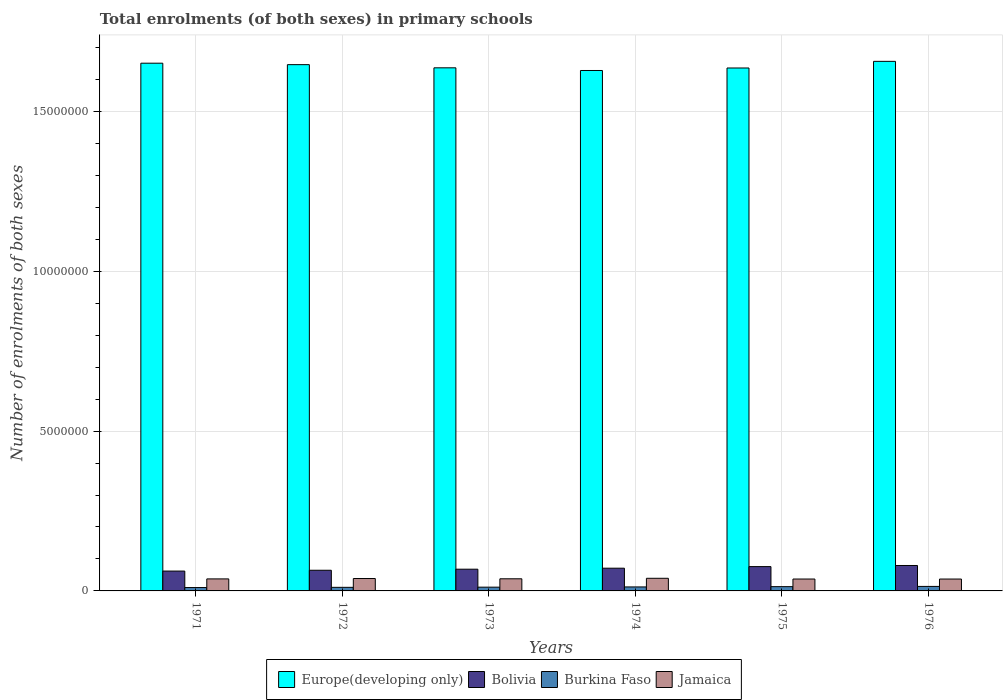How many different coloured bars are there?
Your answer should be very brief. 4. How many groups of bars are there?
Your answer should be very brief. 6. Are the number of bars per tick equal to the number of legend labels?
Your answer should be very brief. Yes. Are the number of bars on each tick of the X-axis equal?
Ensure brevity in your answer.  Yes. How many bars are there on the 3rd tick from the right?
Provide a succinct answer. 4. In how many cases, is the number of bars for a given year not equal to the number of legend labels?
Give a very brief answer. 0. What is the number of enrolments in primary schools in Jamaica in 1975?
Give a very brief answer. 3.72e+05. Across all years, what is the maximum number of enrolments in primary schools in Jamaica?
Keep it short and to the point. 3.95e+05. Across all years, what is the minimum number of enrolments in primary schools in Europe(developing only)?
Offer a very short reply. 1.63e+07. In which year was the number of enrolments in primary schools in Europe(developing only) maximum?
Offer a very short reply. 1976. In which year was the number of enrolments in primary schools in Europe(developing only) minimum?
Your response must be concise. 1974. What is the total number of enrolments in primary schools in Europe(developing only) in the graph?
Your answer should be very brief. 9.86e+07. What is the difference between the number of enrolments in primary schools in Jamaica in 1971 and that in 1974?
Provide a succinct answer. -1.90e+04. What is the difference between the number of enrolments in primary schools in Bolivia in 1973 and the number of enrolments in primary schools in Burkina Faso in 1976?
Offer a very short reply. 5.38e+05. What is the average number of enrolments in primary schools in Burkina Faso per year?
Offer a terse response. 1.22e+05. In the year 1971, what is the difference between the number of enrolments in primary schools in Bolivia and number of enrolments in primary schools in Burkina Faso?
Offer a very short reply. 5.16e+05. What is the ratio of the number of enrolments in primary schools in Burkina Faso in 1973 to that in 1974?
Make the answer very short. 0.94. Is the number of enrolments in primary schools in Burkina Faso in 1971 less than that in 1974?
Keep it short and to the point. Yes. Is the difference between the number of enrolments in primary schools in Bolivia in 1972 and 1975 greater than the difference between the number of enrolments in primary schools in Burkina Faso in 1972 and 1975?
Provide a succinct answer. No. What is the difference between the highest and the second highest number of enrolments in primary schools in Bolivia?
Ensure brevity in your answer.  3.46e+04. What is the difference between the highest and the lowest number of enrolments in primary schools in Bolivia?
Make the answer very short. 1.75e+05. What does the 4th bar from the left in 1975 represents?
Make the answer very short. Jamaica. What does the 4th bar from the right in 1972 represents?
Make the answer very short. Europe(developing only). Are all the bars in the graph horizontal?
Ensure brevity in your answer.  No. How many years are there in the graph?
Make the answer very short. 6. What is the difference between two consecutive major ticks on the Y-axis?
Your answer should be compact. 5.00e+06. Does the graph contain any zero values?
Keep it short and to the point. No. Does the graph contain grids?
Your response must be concise. Yes. What is the title of the graph?
Offer a terse response. Total enrolments (of both sexes) in primary schools. What is the label or title of the X-axis?
Your answer should be compact. Years. What is the label or title of the Y-axis?
Give a very brief answer. Number of enrolments of both sexes. What is the Number of enrolments of both sexes in Europe(developing only) in 1971?
Provide a succinct answer. 1.65e+07. What is the Number of enrolments of both sexes of Bolivia in 1971?
Give a very brief answer. 6.21e+05. What is the Number of enrolments of both sexes in Burkina Faso in 1971?
Make the answer very short. 1.05e+05. What is the Number of enrolments of both sexes of Jamaica in 1971?
Keep it short and to the point. 3.76e+05. What is the Number of enrolments of both sexes in Europe(developing only) in 1972?
Offer a terse response. 1.65e+07. What is the Number of enrolments of both sexes in Bolivia in 1972?
Provide a succinct answer. 6.46e+05. What is the Number of enrolments of both sexes in Burkina Faso in 1972?
Offer a terse response. 1.12e+05. What is the Number of enrolments of both sexes of Jamaica in 1972?
Make the answer very short. 3.88e+05. What is the Number of enrolments of both sexes of Europe(developing only) in 1973?
Offer a terse response. 1.64e+07. What is the Number of enrolments of both sexes of Bolivia in 1973?
Make the answer very short. 6.80e+05. What is the Number of enrolments of both sexes in Burkina Faso in 1973?
Provide a succinct answer. 1.18e+05. What is the Number of enrolments of both sexes in Jamaica in 1973?
Your response must be concise. 3.79e+05. What is the Number of enrolments of both sexes of Europe(developing only) in 1974?
Your answer should be compact. 1.63e+07. What is the Number of enrolments of both sexes of Bolivia in 1974?
Your answer should be very brief. 7.11e+05. What is the Number of enrolments of both sexes in Burkina Faso in 1974?
Offer a terse response. 1.25e+05. What is the Number of enrolments of both sexes in Jamaica in 1974?
Your response must be concise. 3.95e+05. What is the Number of enrolments of both sexes of Europe(developing only) in 1975?
Your answer should be very brief. 1.64e+07. What is the Number of enrolments of both sexes of Bolivia in 1975?
Give a very brief answer. 7.61e+05. What is the Number of enrolments of both sexes of Burkina Faso in 1975?
Keep it short and to the point. 1.34e+05. What is the Number of enrolments of both sexes of Jamaica in 1975?
Offer a very short reply. 3.72e+05. What is the Number of enrolments of both sexes in Europe(developing only) in 1976?
Ensure brevity in your answer.  1.66e+07. What is the Number of enrolments of both sexes in Bolivia in 1976?
Your answer should be very brief. 7.96e+05. What is the Number of enrolments of both sexes in Burkina Faso in 1976?
Keep it short and to the point. 1.41e+05. What is the Number of enrolments of both sexes of Jamaica in 1976?
Your answer should be very brief. 3.72e+05. Across all years, what is the maximum Number of enrolments of both sexes in Europe(developing only)?
Make the answer very short. 1.66e+07. Across all years, what is the maximum Number of enrolments of both sexes of Bolivia?
Make the answer very short. 7.96e+05. Across all years, what is the maximum Number of enrolments of both sexes of Burkina Faso?
Ensure brevity in your answer.  1.41e+05. Across all years, what is the maximum Number of enrolments of both sexes of Jamaica?
Your answer should be compact. 3.95e+05. Across all years, what is the minimum Number of enrolments of both sexes in Europe(developing only)?
Provide a succinct answer. 1.63e+07. Across all years, what is the minimum Number of enrolments of both sexes in Bolivia?
Keep it short and to the point. 6.21e+05. Across all years, what is the minimum Number of enrolments of both sexes of Burkina Faso?
Keep it short and to the point. 1.05e+05. Across all years, what is the minimum Number of enrolments of both sexes of Jamaica?
Give a very brief answer. 3.72e+05. What is the total Number of enrolments of both sexes in Europe(developing only) in the graph?
Provide a succinct answer. 9.86e+07. What is the total Number of enrolments of both sexes of Bolivia in the graph?
Offer a terse response. 4.21e+06. What is the total Number of enrolments of both sexes in Burkina Faso in the graph?
Offer a very short reply. 7.35e+05. What is the total Number of enrolments of both sexes of Jamaica in the graph?
Your answer should be compact. 2.28e+06. What is the difference between the Number of enrolments of both sexes of Europe(developing only) in 1971 and that in 1972?
Offer a terse response. 4.55e+04. What is the difference between the Number of enrolments of both sexes of Bolivia in 1971 and that in 1972?
Your answer should be compact. -2.55e+04. What is the difference between the Number of enrolments of both sexes of Burkina Faso in 1971 and that in 1972?
Keep it short and to the point. -6696. What is the difference between the Number of enrolments of both sexes in Jamaica in 1971 and that in 1972?
Keep it short and to the point. -1.17e+04. What is the difference between the Number of enrolments of both sexes in Europe(developing only) in 1971 and that in 1973?
Ensure brevity in your answer.  1.45e+05. What is the difference between the Number of enrolments of both sexes of Bolivia in 1971 and that in 1973?
Give a very brief answer. -5.87e+04. What is the difference between the Number of enrolments of both sexes of Burkina Faso in 1971 and that in 1973?
Provide a succinct answer. -1.22e+04. What is the difference between the Number of enrolments of both sexes of Jamaica in 1971 and that in 1973?
Offer a terse response. -3421. What is the difference between the Number of enrolments of both sexes in Europe(developing only) in 1971 and that in 1974?
Provide a short and direct response. 2.28e+05. What is the difference between the Number of enrolments of both sexes in Bolivia in 1971 and that in 1974?
Ensure brevity in your answer.  -9.01e+04. What is the difference between the Number of enrolments of both sexes in Burkina Faso in 1971 and that in 1974?
Ensure brevity in your answer.  -1.96e+04. What is the difference between the Number of enrolments of both sexes of Jamaica in 1971 and that in 1974?
Provide a succinct answer. -1.90e+04. What is the difference between the Number of enrolments of both sexes of Europe(developing only) in 1971 and that in 1975?
Offer a terse response. 1.50e+05. What is the difference between the Number of enrolments of both sexes in Bolivia in 1971 and that in 1975?
Your response must be concise. -1.40e+05. What is the difference between the Number of enrolments of both sexes in Burkina Faso in 1971 and that in 1975?
Your answer should be very brief. -2.83e+04. What is the difference between the Number of enrolments of both sexes in Jamaica in 1971 and that in 1975?
Give a very brief answer. 3815. What is the difference between the Number of enrolments of both sexes in Europe(developing only) in 1971 and that in 1976?
Ensure brevity in your answer.  -5.76e+04. What is the difference between the Number of enrolments of both sexes of Bolivia in 1971 and that in 1976?
Keep it short and to the point. -1.75e+05. What is the difference between the Number of enrolments of both sexes of Burkina Faso in 1971 and that in 1976?
Ensure brevity in your answer.  -3.58e+04. What is the difference between the Number of enrolments of both sexes of Jamaica in 1971 and that in 1976?
Provide a short and direct response. 4199. What is the difference between the Number of enrolments of both sexes in Europe(developing only) in 1972 and that in 1973?
Give a very brief answer. 9.94e+04. What is the difference between the Number of enrolments of both sexes in Bolivia in 1972 and that in 1973?
Keep it short and to the point. -3.32e+04. What is the difference between the Number of enrolments of both sexes of Burkina Faso in 1972 and that in 1973?
Your response must be concise. -5534. What is the difference between the Number of enrolments of both sexes in Jamaica in 1972 and that in 1973?
Provide a short and direct response. 8244. What is the difference between the Number of enrolments of both sexes of Europe(developing only) in 1972 and that in 1974?
Your answer should be very brief. 1.83e+05. What is the difference between the Number of enrolments of both sexes in Bolivia in 1972 and that in 1974?
Your answer should be very brief. -6.46e+04. What is the difference between the Number of enrolments of both sexes of Burkina Faso in 1972 and that in 1974?
Your response must be concise. -1.29e+04. What is the difference between the Number of enrolments of both sexes of Jamaica in 1972 and that in 1974?
Your answer should be compact. -7296. What is the difference between the Number of enrolments of both sexes in Europe(developing only) in 1972 and that in 1975?
Your answer should be very brief. 1.05e+05. What is the difference between the Number of enrolments of both sexes of Bolivia in 1972 and that in 1975?
Offer a very short reply. -1.15e+05. What is the difference between the Number of enrolments of both sexes of Burkina Faso in 1972 and that in 1975?
Provide a short and direct response. -2.16e+04. What is the difference between the Number of enrolments of both sexes in Jamaica in 1972 and that in 1975?
Your answer should be compact. 1.55e+04. What is the difference between the Number of enrolments of both sexes of Europe(developing only) in 1972 and that in 1976?
Provide a succinct answer. -1.03e+05. What is the difference between the Number of enrolments of both sexes in Bolivia in 1972 and that in 1976?
Offer a terse response. -1.49e+05. What is the difference between the Number of enrolments of both sexes in Burkina Faso in 1972 and that in 1976?
Provide a short and direct response. -2.91e+04. What is the difference between the Number of enrolments of both sexes of Jamaica in 1972 and that in 1976?
Provide a succinct answer. 1.59e+04. What is the difference between the Number of enrolments of both sexes in Europe(developing only) in 1973 and that in 1974?
Provide a succinct answer. 8.35e+04. What is the difference between the Number of enrolments of both sexes in Bolivia in 1973 and that in 1974?
Make the answer very short. -3.14e+04. What is the difference between the Number of enrolments of both sexes in Burkina Faso in 1973 and that in 1974?
Offer a very short reply. -7385. What is the difference between the Number of enrolments of both sexes of Jamaica in 1973 and that in 1974?
Offer a terse response. -1.55e+04. What is the difference between the Number of enrolments of both sexes of Europe(developing only) in 1973 and that in 1975?
Your answer should be compact. 5116. What is the difference between the Number of enrolments of both sexes of Bolivia in 1973 and that in 1975?
Make the answer very short. -8.14e+04. What is the difference between the Number of enrolments of both sexes in Burkina Faso in 1973 and that in 1975?
Ensure brevity in your answer.  -1.60e+04. What is the difference between the Number of enrolments of both sexes of Jamaica in 1973 and that in 1975?
Your response must be concise. 7236. What is the difference between the Number of enrolments of both sexes in Europe(developing only) in 1973 and that in 1976?
Your answer should be very brief. -2.03e+05. What is the difference between the Number of enrolments of both sexes in Bolivia in 1973 and that in 1976?
Offer a very short reply. -1.16e+05. What is the difference between the Number of enrolments of both sexes in Burkina Faso in 1973 and that in 1976?
Keep it short and to the point. -2.36e+04. What is the difference between the Number of enrolments of both sexes of Jamaica in 1973 and that in 1976?
Give a very brief answer. 7620. What is the difference between the Number of enrolments of both sexes in Europe(developing only) in 1974 and that in 1975?
Give a very brief answer. -7.84e+04. What is the difference between the Number of enrolments of both sexes in Bolivia in 1974 and that in 1975?
Your answer should be very brief. -5.00e+04. What is the difference between the Number of enrolments of both sexes of Burkina Faso in 1974 and that in 1975?
Make the answer very short. -8648. What is the difference between the Number of enrolments of both sexes in Jamaica in 1974 and that in 1975?
Provide a short and direct response. 2.28e+04. What is the difference between the Number of enrolments of both sexes of Europe(developing only) in 1974 and that in 1976?
Offer a terse response. -2.86e+05. What is the difference between the Number of enrolments of both sexes of Bolivia in 1974 and that in 1976?
Offer a terse response. -8.46e+04. What is the difference between the Number of enrolments of both sexes in Burkina Faso in 1974 and that in 1976?
Ensure brevity in your answer.  -1.62e+04. What is the difference between the Number of enrolments of both sexes of Jamaica in 1974 and that in 1976?
Make the answer very short. 2.32e+04. What is the difference between the Number of enrolments of both sexes of Europe(developing only) in 1975 and that in 1976?
Your response must be concise. -2.08e+05. What is the difference between the Number of enrolments of both sexes in Bolivia in 1975 and that in 1976?
Offer a terse response. -3.46e+04. What is the difference between the Number of enrolments of both sexes of Burkina Faso in 1975 and that in 1976?
Your response must be concise. -7563. What is the difference between the Number of enrolments of both sexes in Jamaica in 1975 and that in 1976?
Your answer should be very brief. 384. What is the difference between the Number of enrolments of both sexes of Europe(developing only) in 1971 and the Number of enrolments of both sexes of Bolivia in 1972?
Make the answer very short. 1.59e+07. What is the difference between the Number of enrolments of both sexes of Europe(developing only) in 1971 and the Number of enrolments of both sexes of Burkina Faso in 1972?
Offer a terse response. 1.64e+07. What is the difference between the Number of enrolments of both sexes in Europe(developing only) in 1971 and the Number of enrolments of both sexes in Jamaica in 1972?
Give a very brief answer. 1.61e+07. What is the difference between the Number of enrolments of both sexes of Bolivia in 1971 and the Number of enrolments of both sexes of Burkina Faso in 1972?
Give a very brief answer. 5.09e+05. What is the difference between the Number of enrolments of both sexes of Bolivia in 1971 and the Number of enrolments of both sexes of Jamaica in 1972?
Your answer should be compact. 2.33e+05. What is the difference between the Number of enrolments of both sexes in Burkina Faso in 1971 and the Number of enrolments of both sexes in Jamaica in 1972?
Keep it short and to the point. -2.82e+05. What is the difference between the Number of enrolments of both sexes of Europe(developing only) in 1971 and the Number of enrolments of both sexes of Bolivia in 1973?
Provide a succinct answer. 1.58e+07. What is the difference between the Number of enrolments of both sexes of Europe(developing only) in 1971 and the Number of enrolments of both sexes of Burkina Faso in 1973?
Make the answer very short. 1.64e+07. What is the difference between the Number of enrolments of both sexes of Europe(developing only) in 1971 and the Number of enrolments of both sexes of Jamaica in 1973?
Ensure brevity in your answer.  1.61e+07. What is the difference between the Number of enrolments of both sexes of Bolivia in 1971 and the Number of enrolments of both sexes of Burkina Faso in 1973?
Your response must be concise. 5.03e+05. What is the difference between the Number of enrolments of both sexes in Bolivia in 1971 and the Number of enrolments of both sexes in Jamaica in 1973?
Offer a very short reply. 2.41e+05. What is the difference between the Number of enrolments of both sexes of Burkina Faso in 1971 and the Number of enrolments of both sexes of Jamaica in 1973?
Provide a short and direct response. -2.74e+05. What is the difference between the Number of enrolments of both sexes of Europe(developing only) in 1971 and the Number of enrolments of both sexes of Bolivia in 1974?
Offer a very short reply. 1.58e+07. What is the difference between the Number of enrolments of both sexes of Europe(developing only) in 1971 and the Number of enrolments of both sexes of Burkina Faso in 1974?
Give a very brief answer. 1.64e+07. What is the difference between the Number of enrolments of both sexes in Europe(developing only) in 1971 and the Number of enrolments of both sexes in Jamaica in 1974?
Offer a very short reply. 1.61e+07. What is the difference between the Number of enrolments of both sexes of Bolivia in 1971 and the Number of enrolments of both sexes of Burkina Faso in 1974?
Make the answer very short. 4.96e+05. What is the difference between the Number of enrolments of both sexes in Bolivia in 1971 and the Number of enrolments of both sexes in Jamaica in 1974?
Offer a very short reply. 2.26e+05. What is the difference between the Number of enrolments of both sexes in Burkina Faso in 1971 and the Number of enrolments of both sexes in Jamaica in 1974?
Your answer should be compact. -2.90e+05. What is the difference between the Number of enrolments of both sexes in Europe(developing only) in 1971 and the Number of enrolments of both sexes in Bolivia in 1975?
Give a very brief answer. 1.58e+07. What is the difference between the Number of enrolments of both sexes of Europe(developing only) in 1971 and the Number of enrolments of both sexes of Burkina Faso in 1975?
Provide a short and direct response. 1.64e+07. What is the difference between the Number of enrolments of both sexes of Europe(developing only) in 1971 and the Number of enrolments of both sexes of Jamaica in 1975?
Ensure brevity in your answer.  1.61e+07. What is the difference between the Number of enrolments of both sexes in Bolivia in 1971 and the Number of enrolments of both sexes in Burkina Faso in 1975?
Your answer should be very brief. 4.87e+05. What is the difference between the Number of enrolments of both sexes in Bolivia in 1971 and the Number of enrolments of both sexes in Jamaica in 1975?
Your answer should be very brief. 2.49e+05. What is the difference between the Number of enrolments of both sexes of Burkina Faso in 1971 and the Number of enrolments of both sexes of Jamaica in 1975?
Your answer should be very brief. -2.67e+05. What is the difference between the Number of enrolments of both sexes in Europe(developing only) in 1971 and the Number of enrolments of both sexes in Bolivia in 1976?
Ensure brevity in your answer.  1.57e+07. What is the difference between the Number of enrolments of both sexes of Europe(developing only) in 1971 and the Number of enrolments of both sexes of Burkina Faso in 1976?
Offer a very short reply. 1.64e+07. What is the difference between the Number of enrolments of both sexes of Europe(developing only) in 1971 and the Number of enrolments of both sexes of Jamaica in 1976?
Offer a very short reply. 1.61e+07. What is the difference between the Number of enrolments of both sexes of Bolivia in 1971 and the Number of enrolments of both sexes of Burkina Faso in 1976?
Make the answer very short. 4.80e+05. What is the difference between the Number of enrolments of both sexes of Bolivia in 1971 and the Number of enrolments of both sexes of Jamaica in 1976?
Your answer should be compact. 2.49e+05. What is the difference between the Number of enrolments of both sexes of Burkina Faso in 1971 and the Number of enrolments of both sexes of Jamaica in 1976?
Give a very brief answer. -2.67e+05. What is the difference between the Number of enrolments of both sexes of Europe(developing only) in 1972 and the Number of enrolments of both sexes of Bolivia in 1973?
Ensure brevity in your answer.  1.58e+07. What is the difference between the Number of enrolments of both sexes of Europe(developing only) in 1972 and the Number of enrolments of both sexes of Burkina Faso in 1973?
Keep it short and to the point. 1.63e+07. What is the difference between the Number of enrolments of both sexes in Europe(developing only) in 1972 and the Number of enrolments of both sexes in Jamaica in 1973?
Your response must be concise. 1.61e+07. What is the difference between the Number of enrolments of both sexes of Bolivia in 1972 and the Number of enrolments of both sexes of Burkina Faso in 1973?
Your response must be concise. 5.29e+05. What is the difference between the Number of enrolments of both sexes in Bolivia in 1972 and the Number of enrolments of both sexes in Jamaica in 1973?
Make the answer very short. 2.67e+05. What is the difference between the Number of enrolments of both sexes of Burkina Faso in 1972 and the Number of enrolments of both sexes of Jamaica in 1973?
Provide a short and direct response. -2.67e+05. What is the difference between the Number of enrolments of both sexes in Europe(developing only) in 1972 and the Number of enrolments of both sexes in Bolivia in 1974?
Offer a very short reply. 1.58e+07. What is the difference between the Number of enrolments of both sexes of Europe(developing only) in 1972 and the Number of enrolments of both sexes of Burkina Faso in 1974?
Provide a succinct answer. 1.63e+07. What is the difference between the Number of enrolments of both sexes in Europe(developing only) in 1972 and the Number of enrolments of both sexes in Jamaica in 1974?
Provide a short and direct response. 1.61e+07. What is the difference between the Number of enrolments of both sexes of Bolivia in 1972 and the Number of enrolments of both sexes of Burkina Faso in 1974?
Make the answer very short. 5.21e+05. What is the difference between the Number of enrolments of both sexes of Bolivia in 1972 and the Number of enrolments of both sexes of Jamaica in 1974?
Your answer should be very brief. 2.51e+05. What is the difference between the Number of enrolments of both sexes in Burkina Faso in 1972 and the Number of enrolments of both sexes in Jamaica in 1974?
Offer a very short reply. -2.83e+05. What is the difference between the Number of enrolments of both sexes of Europe(developing only) in 1972 and the Number of enrolments of both sexes of Bolivia in 1975?
Provide a succinct answer. 1.57e+07. What is the difference between the Number of enrolments of both sexes in Europe(developing only) in 1972 and the Number of enrolments of both sexes in Burkina Faso in 1975?
Make the answer very short. 1.63e+07. What is the difference between the Number of enrolments of both sexes of Europe(developing only) in 1972 and the Number of enrolments of both sexes of Jamaica in 1975?
Provide a short and direct response. 1.61e+07. What is the difference between the Number of enrolments of both sexes of Bolivia in 1972 and the Number of enrolments of both sexes of Burkina Faso in 1975?
Offer a very short reply. 5.13e+05. What is the difference between the Number of enrolments of both sexes of Bolivia in 1972 and the Number of enrolments of both sexes of Jamaica in 1975?
Provide a short and direct response. 2.74e+05. What is the difference between the Number of enrolments of both sexes in Burkina Faso in 1972 and the Number of enrolments of both sexes in Jamaica in 1975?
Keep it short and to the point. -2.60e+05. What is the difference between the Number of enrolments of both sexes of Europe(developing only) in 1972 and the Number of enrolments of both sexes of Bolivia in 1976?
Offer a terse response. 1.57e+07. What is the difference between the Number of enrolments of both sexes of Europe(developing only) in 1972 and the Number of enrolments of both sexes of Burkina Faso in 1976?
Your answer should be very brief. 1.63e+07. What is the difference between the Number of enrolments of both sexes of Europe(developing only) in 1972 and the Number of enrolments of both sexes of Jamaica in 1976?
Make the answer very short. 1.61e+07. What is the difference between the Number of enrolments of both sexes in Bolivia in 1972 and the Number of enrolments of both sexes in Burkina Faso in 1976?
Your answer should be compact. 5.05e+05. What is the difference between the Number of enrolments of both sexes in Bolivia in 1972 and the Number of enrolments of both sexes in Jamaica in 1976?
Offer a terse response. 2.74e+05. What is the difference between the Number of enrolments of both sexes in Burkina Faso in 1972 and the Number of enrolments of both sexes in Jamaica in 1976?
Provide a succinct answer. -2.60e+05. What is the difference between the Number of enrolments of both sexes in Europe(developing only) in 1973 and the Number of enrolments of both sexes in Bolivia in 1974?
Provide a succinct answer. 1.57e+07. What is the difference between the Number of enrolments of both sexes of Europe(developing only) in 1973 and the Number of enrolments of both sexes of Burkina Faso in 1974?
Provide a short and direct response. 1.62e+07. What is the difference between the Number of enrolments of both sexes of Europe(developing only) in 1973 and the Number of enrolments of both sexes of Jamaica in 1974?
Provide a succinct answer. 1.60e+07. What is the difference between the Number of enrolments of both sexes in Bolivia in 1973 and the Number of enrolments of both sexes in Burkina Faso in 1974?
Ensure brevity in your answer.  5.55e+05. What is the difference between the Number of enrolments of both sexes of Bolivia in 1973 and the Number of enrolments of both sexes of Jamaica in 1974?
Your answer should be very brief. 2.85e+05. What is the difference between the Number of enrolments of both sexes in Burkina Faso in 1973 and the Number of enrolments of both sexes in Jamaica in 1974?
Ensure brevity in your answer.  -2.77e+05. What is the difference between the Number of enrolments of both sexes of Europe(developing only) in 1973 and the Number of enrolments of both sexes of Bolivia in 1975?
Ensure brevity in your answer.  1.56e+07. What is the difference between the Number of enrolments of both sexes in Europe(developing only) in 1973 and the Number of enrolments of both sexes in Burkina Faso in 1975?
Provide a succinct answer. 1.62e+07. What is the difference between the Number of enrolments of both sexes in Europe(developing only) in 1973 and the Number of enrolments of both sexes in Jamaica in 1975?
Your answer should be compact. 1.60e+07. What is the difference between the Number of enrolments of both sexes of Bolivia in 1973 and the Number of enrolments of both sexes of Burkina Faso in 1975?
Keep it short and to the point. 5.46e+05. What is the difference between the Number of enrolments of both sexes of Bolivia in 1973 and the Number of enrolments of both sexes of Jamaica in 1975?
Offer a very short reply. 3.07e+05. What is the difference between the Number of enrolments of both sexes of Burkina Faso in 1973 and the Number of enrolments of both sexes of Jamaica in 1975?
Your answer should be very brief. -2.55e+05. What is the difference between the Number of enrolments of both sexes in Europe(developing only) in 1973 and the Number of enrolments of both sexes in Bolivia in 1976?
Your answer should be very brief. 1.56e+07. What is the difference between the Number of enrolments of both sexes in Europe(developing only) in 1973 and the Number of enrolments of both sexes in Burkina Faso in 1976?
Your answer should be compact. 1.62e+07. What is the difference between the Number of enrolments of both sexes in Europe(developing only) in 1973 and the Number of enrolments of both sexes in Jamaica in 1976?
Give a very brief answer. 1.60e+07. What is the difference between the Number of enrolments of both sexes in Bolivia in 1973 and the Number of enrolments of both sexes in Burkina Faso in 1976?
Make the answer very short. 5.38e+05. What is the difference between the Number of enrolments of both sexes in Bolivia in 1973 and the Number of enrolments of both sexes in Jamaica in 1976?
Your answer should be very brief. 3.08e+05. What is the difference between the Number of enrolments of both sexes of Burkina Faso in 1973 and the Number of enrolments of both sexes of Jamaica in 1976?
Keep it short and to the point. -2.54e+05. What is the difference between the Number of enrolments of both sexes of Europe(developing only) in 1974 and the Number of enrolments of both sexes of Bolivia in 1975?
Ensure brevity in your answer.  1.55e+07. What is the difference between the Number of enrolments of both sexes in Europe(developing only) in 1974 and the Number of enrolments of both sexes in Burkina Faso in 1975?
Your response must be concise. 1.61e+07. What is the difference between the Number of enrolments of both sexes in Europe(developing only) in 1974 and the Number of enrolments of both sexes in Jamaica in 1975?
Offer a very short reply. 1.59e+07. What is the difference between the Number of enrolments of both sexes in Bolivia in 1974 and the Number of enrolments of both sexes in Burkina Faso in 1975?
Your answer should be compact. 5.77e+05. What is the difference between the Number of enrolments of both sexes in Bolivia in 1974 and the Number of enrolments of both sexes in Jamaica in 1975?
Give a very brief answer. 3.39e+05. What is the difference between the Number of enrolments of both sexes of Burkina Faso in 1974 and the Number of enrolments of both sexes of Jamaica in 1975?
Make the answer very short. -2.47e+05. What is the difference between the Number of enrolments of both sexes of Europe(developing only) in 1974 and the Number of enrolments of both sexes of Bolivia in 1976?
Your response must be concise. 1.55e+07. What is the difference between the Number of enrolments of both sexes of Europe(developing only) in 1974 and the Number of enrolments of both sexes of Burkina Faso in 1976?
Offer a very short reply. 1.61e+07. What is the difference between the Number of enrolments of both sexes of Europe(developing only) in 1974 and the Number of enrolments of both sexes of Jamaica in 1976?
Offer a very short reply. 1.59e+07. What is the difference between the Number of enrolments of both sexes of Bolivia in 1974 and the Number of enrolments of both sexes of Burkina Faso in 1976?
Your answer should be very brief. 5.70e+05. What is the difference between the Number of enrolments of both sexes of Bolivia in 1974 and the Number of enrolments of both sexes of Jamaica in 1976?
Give a very brief answer. 3.39e+05. What is the difference between the Number of enrolments of both sexes of Burkina Faso in 1974 and the Number of enrolments of both sexes of Jamaica in 1976?
Keep it short and to the point. -2.47e+05. What is the difference between the Number of enrolments of both sexes in Europe(developing only) in 1975 and the Number of enrolments of both sexes in Bolivia in 1976?
Keep it short and to the point. 1.56e+07. What is the difference between the Number of enrolments of both sexes of Europe(developing only) in 1975 and the Number of enrolments of both sexes of Burkina Faso in 1976?
Ensure brevity in your answer.  1.62e+07. What is the difference between the Number of enrolments of both sexes of Europe(developing only) in 1975 and the Number of enrolments of both sexes of Jamaica in 1976?
Your answer should be compact. 1.60e+07. What is the difference between the Number of enrolments of both sexes of Bolivia in 1975 and the Number of enrolments of both sexes of Burkina Faso in 1976?
Offer a terse response. 6.20e+05. What is the difference between the Number of enrolments of both sexes of Bolivia in 1975 and the Number of enrolments of both sexes of Jamaica in 1976?
Offer a very short reply. 3.89e+05. What is the difference between the Number of enrolments of both sexes in Burkina Faso in 1975 and the Number of enrolments of both sexes in Jamaica in 1976?
Make the answer very short. -2.38e+05. What is the average Number of enrolments of both sexes of Europe(developing only) per year?
Your answer should be very brief. 1.64e+07. What is the average Number of enrolments of both sexes in Bolivia per year?
Offer a terse response. 7.02e+05. What is the average Number of enrolments of both sexes of Burkina Faso per year?
Offer a very short reply. 1.22e+05. What is the average Number of enrolments of both sexes in Jamaica per year?
Your answer should be compact. 3.80e+05. In the year 1971, what is the difference between the Number of enrolments of both sexes of Europe(developing only) and Number of enrolments of both sexes of Bolivia?
Offer a terse response. 1.59e+07. In the year 1971, what is the difference between the Number of enrolments of both sexes of Europe(developing only) and Number of enrolments of both sexes of Burkina Faso?
Offer a very short reply. 1.64e+07. In the year 1971, what is the difference between the Number of enrolments of both sexes in Europe(developing only) and Number of enrolments of both sexes in Jamaica?
Offer a terse response. 1.61e+07. In the year 1971, what is the difference between the Number of enrolments of both sexes of Bolivia and Number of enrolments of both sexes of Burkina Faso?
Offer a very short reply. 5.16e+05. In the year 1971, what is the difference between the Number of enrolments of both sexes of Bolivia and Number of enrolments of both sexes of Jamaica?
Give a very brief answer. 2.45e+05. In the year 1971, what is the difference between the Number of enrolments of both sexes in Burkina Faso and Number of enrolments of both sexes in Jamaica?
Provide a succinct answer. -2.71e+05. In the year 1972, what is the difference between the Number of enrolments of both sexes of Europe(developing only) and Number of enrolments of both sexes of Bolivia?
Give a very brief answer. 1.58e+07. In the year 1972, what is the difference between the Number of enrolments of both sexes of Europe(developing only) and Number of enrolments of both sexes of Burkina Faso?
Provide a short and direct response. 1.64e+07. In the year 1972, what is the difference between the Number of enrolments of both sexes in Europe(developing only) and Number of enrolments of both sexes in Jamaica?
Offer a very short reply. 1.61e+07. In the year 1972, what is the difference between the Number of enrolments of both sexes of Bolivia and Number of enrolments of both sexes of Burkina Faso?
Make the answer very short. 5.34e+05. In the year 1972, what is the difference between the Number of enrolments of both sexes in Bolivia and Number of enrolments of both sexes in Jamaica?
Give a very brief answer. 2.59e+05. In the year 1972, what is the difference between the Number of enrolments of both sexes in Burkina Faso and Number of enrolments of both sexes in Jamaica?
Provide a succinct answer. -2.76e+05. In the year 1973, what is the difference between the Number of enrolments of both sexes in Europe(developing only) and Number of enrolments of both sexes in Bolivia?
Your answer should be compact. 1.57e+07. In the year 1973, what is the difference between the Number of enrolments of both sexes of Europe(developing only) and Number of enrolments of both sexes of Burkina Faso?
Make the answer very short. 1.62e+07. In the year 1973, what is the difference between the Number of enrolments of both sexes in Europe(developing only) and Number of enrolments of both sexes in Jamaica?
Provide a succinct answer. 1.60e+07. In the year 1973, what is the difference between the Number of enrolments of both sexes of Bolivia and Number of enrolments of both sexes of Burkina Faso?
Offer a terse response. 5.62e+05. In the year 1973, what is the difference between the Number of enrolments of both sexes in Bolivia and Number of enrolments of both sexes in Jamaica?
Offer a very short reply. 3.00e+05. In the year 1973, what is the difference between the Number of enrolments of both sexes of Burkina Faso and Number of enrolments of both sexes of Jamaica?
Provide a succinct answer. -2.62e+05. In the year 1974, what is the difference between the Number of enrolments of both sexes of Europe(developing only) and Number of enrolments of both sexes of Bolivia?
Keep it short and to the point. 1.56e+07. In the year 1974, what is the difference between the Number of enrolments of both sexes in Europe(developing only) and Number of enrolments of both sexes in Burkina Faso?
Give a very brief answer. 1.62e+07. In the year 1974, what is the difference between the Number of enrolments of both sexes in Europe(developing only) and Number of enrolments of both sexes in Jamaica?
Your response must be concise. 1.59e+07. In the year 1974, what is the difference between the Number of enrolments of both sexes of Bolivia and Number of enrolments of both sexes of Burkina Faso?
Keep it short and to the point. 5.86e+05. In the year 1974, what is the difference between the Number of enrolments of both sexes of Bolivia and Number of enrolments of both sexes of Jamaica?
Keep it short and to the point. 3.16e+05. In the year 1974, what is the difference between the Number of enrolments of both sexes in Burkina Faso and Number of enrolments of both sexes in Jamaica?
Give a very brief answer. -2.70e+05. In the year 1975, what is the difference between the Number of enrolments of both sexes in Europe(developing only) and Number of enrolments of both sexes in Bolivia?
Your answer should be compact. 1.56e+07. In the year 1975, what is the difference between the Number of enrolments of both sexes in Europe(developing only) and Number of enrolments of both sexes in Burkina Faso?
Offer a terse response. 1.62e+07. In the year 1975, what is the difference between the Number of enrolments of both sexes in Europe(developing only) and Number of enrolments of both sexes in Jamaica?
Ensure brevity in your answer.  1.60e+07. In the year 1975, what is the difference between the Number of enrolments of both sexes in Bolivia and Number of enrolments of both sexes in Burkina Faso?
Ensure brevity in your answer.  6.27e+05. In the year 1975, what is the difference between the Number of enrolments of both sexes in Bolivia and Number of enrolments of both sexes in Jamaica?
Your answer should be very brief. 3.89e+05. In the year 1975, what is the difference between the Number of enrolments of both sexes in Burkina Faso and Number of enrolments of both sexes in Jamaica?
Give a very brief answer. -2.39e+05. In the year 1976, what is the difference between the Number of enrolments of both sexes in Europe(developing only) and Number of enrolments of both sexes in Bolivia?
Offer a terse response. 1.58e+07. In the year 1976, what is the difference between the Number of enrolments of both sexes in Europe(developing only) and Number of enrolments of both sexes in Burkina Faso?
Your answer should be very brief. 1.64e+07. In the year 1976, what is the difference between the Number of enrolments of both sexes of Europe(developing only) and Number of enrolments of both sexes of Jamaica?
Your response must be concise. 1.62e+07. In the year 1976, what is the difference between the Number of enrolments of both sexes of Bolivia and Number of enrolments of both sexes of Burkina Faso?
Keep it short and to the point. 6.54e+05. In the year 1976, what is the difference between the Number of enrolments of both sexes in Bolivia and Number of enrolments of both sexes in Jamaica?
Offer a terse response. 4.24e+05. In the year 1976, what is the difference between the Number of enrolments of both sexes of Burkina Faso and Number of enrolments of both sexes of Jamaica?
Give a very brief answer. -2.31e+05. What is the ratio of the Number of enrolments of both sexes of Bolivia in 1971 to that in 1972?
Provide a short and direct response. 0.96. What is the ratio of the Number of enrolments of both sexes in Burkina Faso in 1971 to that in 1972?
Your answer should be compact. 0.94. What is the ratio of the Number of enrolments of both sexes of Jamaica in 1971 to that in 1972?
Give a very brief answer. 0.97. What is the ratio of the Number of enrolments of both sexes of Europe(developing only) in 1971 to that in 1973?
Keep it short and to the point. 1.01. What is the ratio of the Number of enrolments of both sexes in Bolivia in 1971 to that in 1973?
Your answer should be very brief. 0.91. What is the ratio of the Number of enrolments of both sexes in Burkina Faso in 1971 to that in 1973?
Ensure brevity in your answer.  0.9. What is the ratio of the Number of enrolments of both sexes of Jamaica in 1971 to that in 1973?
Ensure brevity in your answer.  0.99. What is the ratio of the Number of enrolments of both sexes in Bolivia in 1971 to that in 1974?
Your response must be concise. 0.87. What is the ratio of the Number of enrolments of both sexes in Burkina Faso in 1971 to that in 1974?
Provide a short and direct response. 0.84. What is the ratio of the Number of enrolments of both sexes in Europe(developing only) in 1971 to that in 1975?
Your response must be concise. 1.01. What is the ratio of the Number of enrolments of both sexes in Bolivia in 1971 to that in 1975?
Ensure brevity in your answer.  0.82. What is the ratio of the Number of enrolments of both sexes of Burkina Faso in 1971 to that in 1975?
Your answer should be very brief. 0.79. What is the ratio of the Number of enrolments of both sexes of Jamaica in 1971 to that in 1975?
Your answer should be compact. 1.01. What is the ratio of the Number of enrolments of both sexes of Bolivia in 1971 to that in 1976?
Give a very brief answer. 0.78. What is the ratio of the Number of enrolments of both sexes of Burkina Faso in 1971 to that in 1976?
Provide a succinct answer. 0.75. What is the ratio of the Number of enrolments of both sexes in Jamaica in 1971 to that in 1976?
Offer a very short reply. 1.01. What is the ratio of the Number of enrolments of both sexes in Bolivia in 1972 to that in 1973?
Your response must be concise. 0.95. What is the ratio of the Number of enrolments of both sexes of Burkina Faso in 1972 to that in 1973?
Ensure brevity in your answer.  0.95. What is the ratio of the Number of enrolments of both sexes of Jamaica in 1972 to that in 1973?
Offer a very short reply. 1.02. What is the ratio of the Number of enrolments of both sexes in Europe(developing only) in 1972 to that in 1974?
Give a very brief answer. 1.01. What is the ratio of the Number of enrolments of both sexes in Burkina Faso in 1972 to that in 1974?
Provide a succinct answer. 0.9. What is the ratio of the Number of enrolments of both sexes of Jamaica in 1972 to that in 1974?
Offer a terse response. 0.98. What is the ratio of the Number of enrolments of both sexes in Europe(developing only) in 1972 to that in 1975?
Ensure brevity in your answer.  1.01. What is the ratio of the Number of enrolments of both sexes of Bolivia in 1972 to that in 1975?
Ensure brevity in your answer.  0.85. What is the ratio of the Number of enrolments of both sexes of Burkina Faso in 1972 to that in 1975?
Give a very brief answer. 0.84. What is the ratio of the Number of enrolments of both sexes of Jamaica in 1972 to that in 1975?
Keep it short and to the point. 1.04. What is the ratio of the Number of enrolments of both sexes in Europe(developing only) in 1972 to that in 1976?
Your response must be concise. 0.99. What is the ratio of the Number of enrolments of both sexes of Bolivia in 1972 to that in 1976?
Offer a terse response. 0.81. What is the ratio of the Number of enrolments of both sexes of Burkina Faso in 1972 to that in 1976?
Provide a short and direct response. 0.79. What is the ratio of the Number of enrolments of both sexes in Jamaica in 1972 to that in 1976?
Offer a terse response. 1.04. What is the ratio of the Number of enrolments of both sexes of Bolivia in 1973 to that in 1974?
Offer a terse response. 0.96. What is the ratio of the Number of enrolments of both sexes of Burkina Faso in 1973 to that in 1974?
Your answer should be very brief. 0.94. What is the ratio of the Number of enrolments of both sexes of Jamaica in 1973 to that in 1974?
Offer a terse response. 0.96. What is the ratio of the Number of enrolments of both sexes of Europe(developing only) in 1973 to that in 1975?
Offer a very short reply. 1. What is the ratio of the Number of enrolments of both sexes of Bolivia in 1973 to that in 1975?
Ensure brevity in your answer.  0.89. What is the ratio of the Number of enrolments of both sexes of Jamaica in 1973 to that in 1975?
Offer a very short reply. 1.02. What is the ratio of the Number of enrolments of both sexes of Europe(developing only) in 1973 to that in 1976?
Offer a very short reply. 0.99. What is the ratio of the Number of enrolments of both sexes in Bolivia in 1973 to that in 1976?
Provide a succinct answer. 0.85. What is the ratio of the Number of enrolments of both sexes of Burkina Faso in 1973 to that in 1976?
Offer a terse response. 0.83. What is the ratio of the Number of enrolments of both sexes in Jamaica in 1973 to that in 1976?
Keep it short and to the point. 1.02. What is the ratio of the Number of enrolments of both sexes in Europe(developing only) in 1974 to that in 1975?
Ensure brevity in your answer.  1. What is the ratio of the Number of enrolments of both sexes of Bolivia in 1974 to that in 1975?
Your answer should be very brief. 0.93. What is the ratio of the Number of enrolments of both sexes in Burkina Faso in 1974 to that in 1975?
Your answer should be very brief. 0.94. What is the ratio of the Number of enrolments of both sexes in Jamaica in 1974 to that in 1975?
Make the answer very short. 1.06. What is the ratio of the Number of enrolments of both sexes in Europe(developing only) in 1974 to that in 1976?
Provide a succinct answer. 0.98. What is the ratio of the Number of enrolments of both sexes in Bolivia in 1974 to that in 1976?
Your answer should be very brief. 0.89. What is the ratio of the Number of enrolments of both sexes of Burkina Faso in 1974 to that in 1976?
Keep it short and to the point. 0.89. What is the ratio of the Number of enrolments of both sexes of Jamaica in 1974 to that in 1976?
Your response must be concise. 1.06. What is the ratio of the Number of enrolments of both sexes of Europe(developing only) in 1975 to that in 1976?
Provide a succinct answer. 0.99. What is the ratio of the Number of enrolments of both sexes of Bolivia in 1975 to that in 1976?
Your response must be concise. 0.96. What is the ratio of the Number of enrolments of both sexes in Burkina Faso in 1975 to that in 1976?
Keep it short and to the point. 0.95. What is the ratio of the Number of enrolments of both sexes of Jamaica in 1975 to that in 1976?
Provide a short and direct response. 1. What is the difference between the highest and the second highest Number of enrolments of both sexes in Europe(developing only)?
Your answer should be very brief. 5.76e+04. What is the difference between the highest and the second highest Number of enrolments of both sexes of Bolivia?
Offer a very short reply. 3.46e+04. What is the difference between the highest and the second highest Number of enrolments of both sexes of Burkina Faso?
Make the answer very short. 7563. What is the difference between the highest and the second highest Number of enrolments of both sexes of Jamaica?
Make the answer very short. 7296. What is the difference between the highest and the lowest Number of enrolments of both sexes of Europe(developing only)?
Make the answer very short. 2.86e+05. What is the difference between the highest and the lowest Number of enrolments of both sexes of Bolivia?
Ensure brevity in your answer.  1.75e+05. What is the difference between the highest and the lowest Number of enrolments of both sexes of Burkina Faso?
Your response must be concise. 3.58e+04. What is the difference between the highest and the lowest Number of enrolments of both sexes of Jamaica?
Your answer should be very brief. 2.32e+04. 